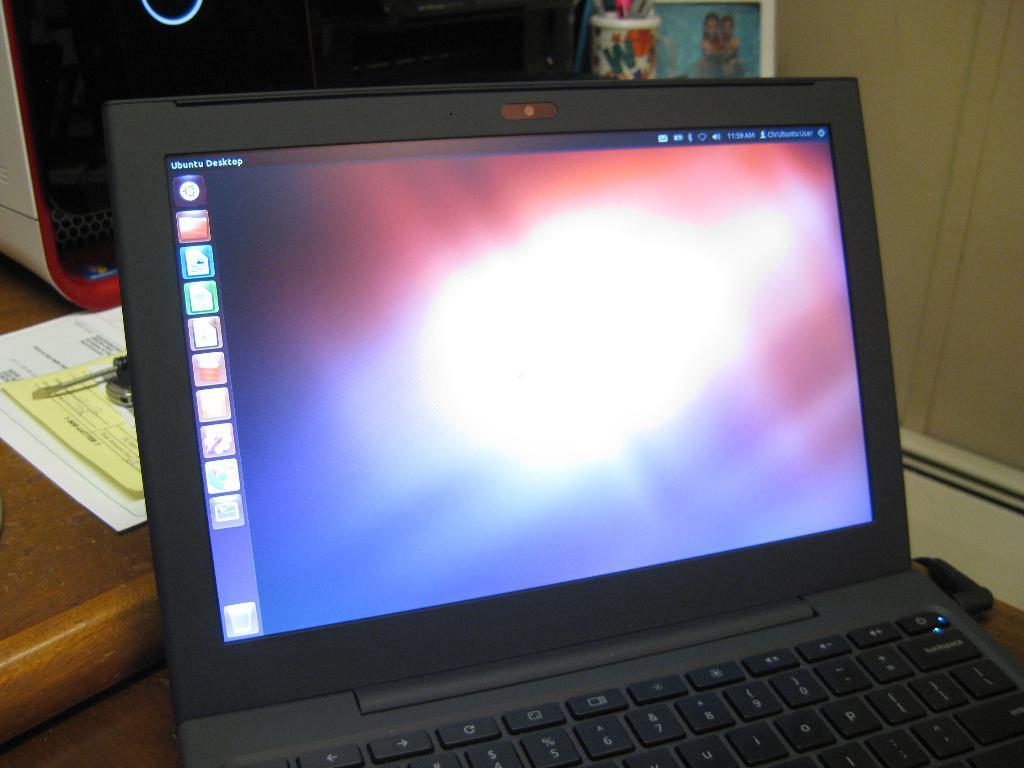What operating system is this laptop using?
Provide a succinct answer. Ubuntu. What time is it?
Offer a terse response. 11:59. 